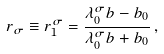Convert formula to latex. <formula><loc_0><loc_0><loc_500><loc_500>r _ { \sigma } \equiv r _ { 1 } ^ { \sigma } = \frac { \lambda _ { 0 } ^ { \sigma } b - b _ { 0 } } { \lambda _ { 0 } ^ { \sigma } b + b _ { 0 } } \, ,</formula> 